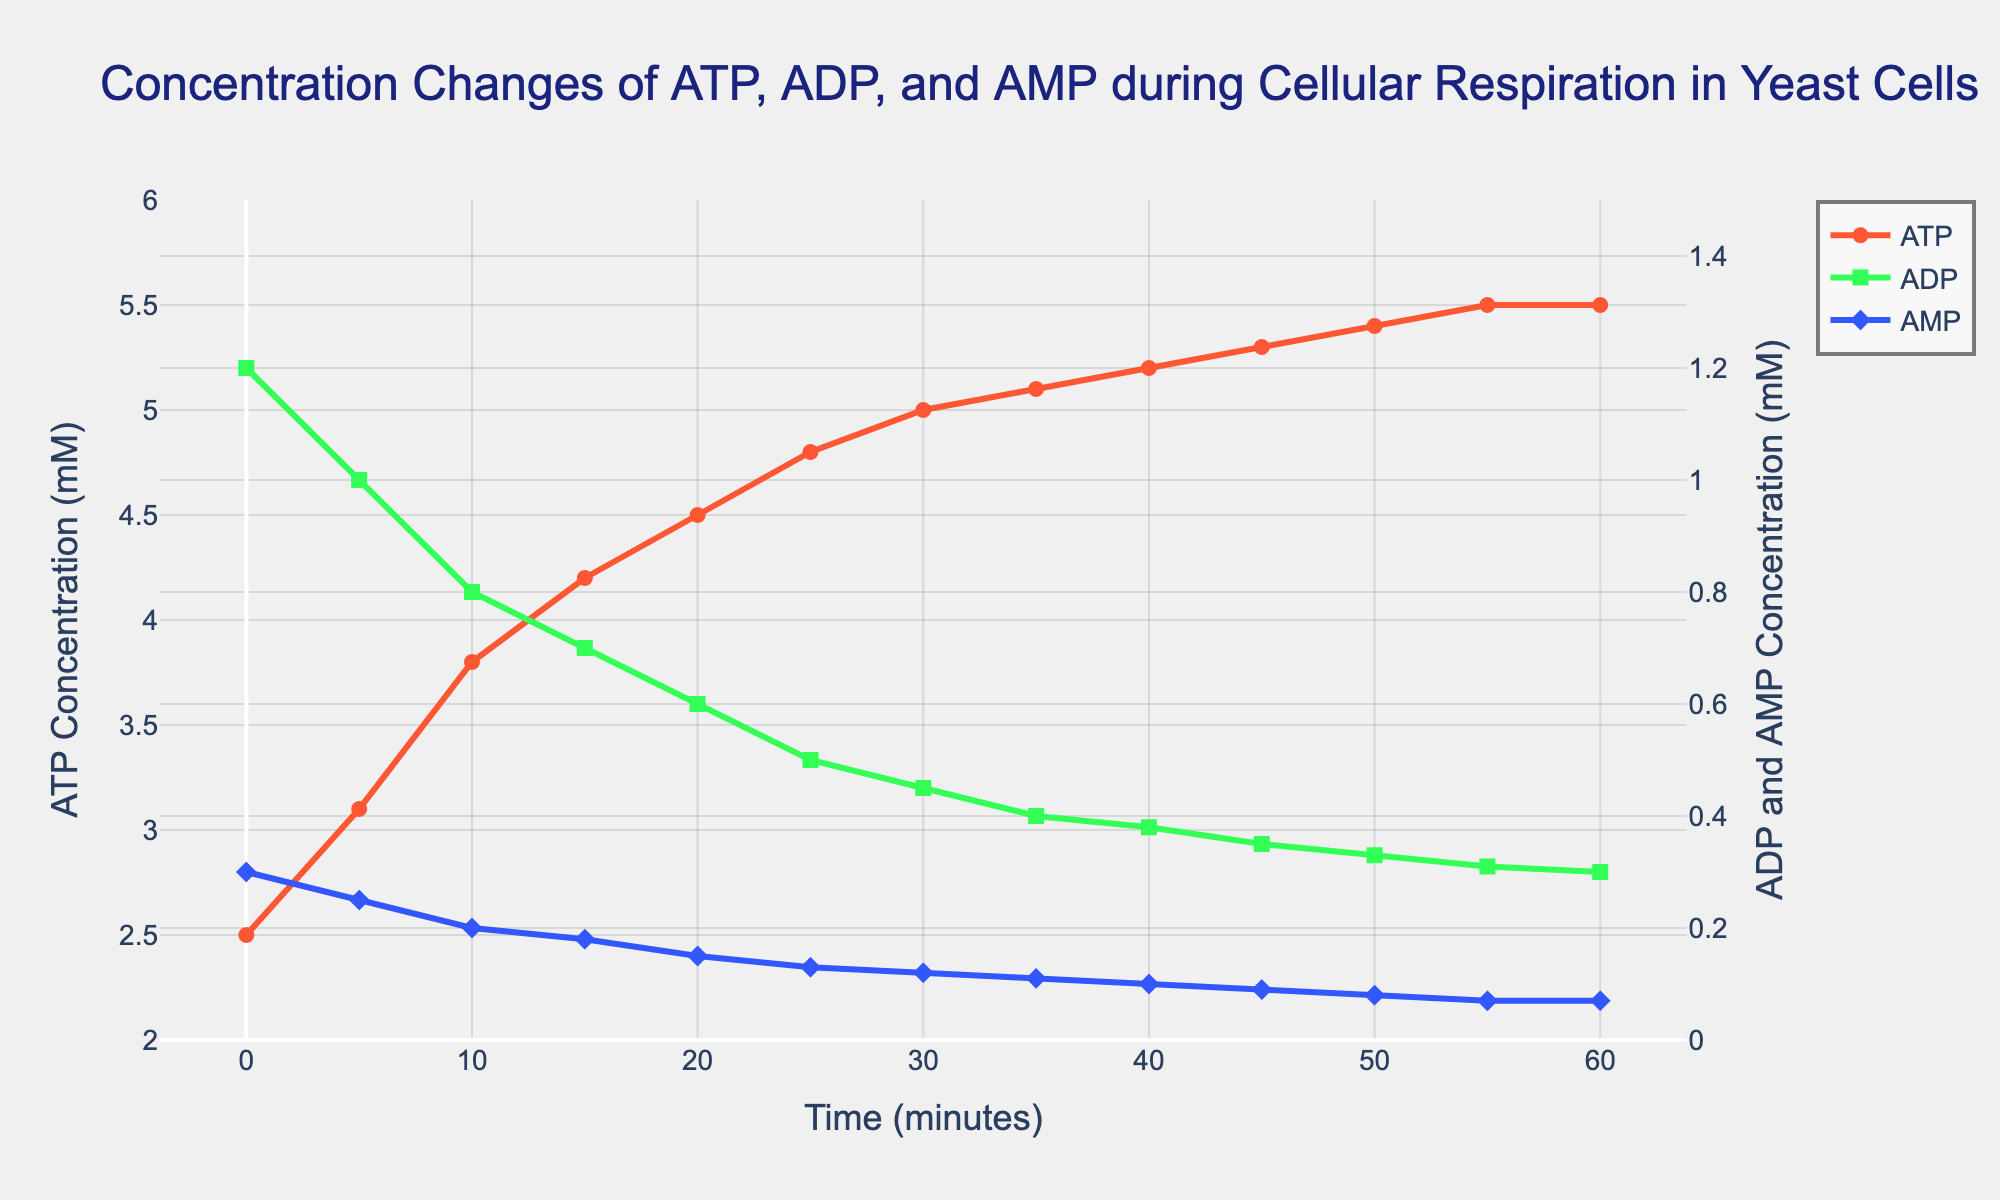Which compound has the highest concentration at the start (0 min)? By examining the values at the start (0 min), ATP has the highest concentration of 2.5 mM compared to ADP (1.2 mM) and AMP (0.3 mM)
Answer: ATP How much does the ATP concentration increase from 0 min to 60 min? The concentration of ATP at 0 min is 2.5 mM and at 60 min is 5.5 mM. The increase is 5.5 - 2.5 = 3 mM
Answer: 3 mM Between which time intervals does the ATP concentration first exceed 4 mM? ATP first exceeds 4 mM between 10 and 15 minutes (4.2 mM at 15 minutes)
Answer: 10-15 minutes What is the difference between the concentrations of ATP and ADP at 45 min? At 45 min, ATP is 5.3 mM and ADP is 0.35 mM. The difference is 5.3 - 0.35 = 4.95 mM
Answer: 4.95 mM Which compound shows the smallest decrease over time? By comparing the changes in ADP and AMP, AMP goes from 0.3 mM to 0.07 mM, a decrease of 0.23 mM, while ADP goes from 1.2 mM to 0.3 mM, a decrease of 0.9 mM. AMP's decrease is smaller
Answer: AMP At what time does ATP reach its maximum concentration? ATP concentration reaches its peak at 55 min and stays constant till 60 min at 5.5 mM
Answer: 55 min Order the concentration of ATP at different time points: 0 min, 30 min, and 60 min, from lowest to highest. Concentrations are 2.5 mM at 0 min, 5.0 mM at 30 min, and 5.5 mM at 60 min. Ordered from lowest to highest: 0 min < 30 min < 60 min
Answer: 0 min < 30 min < 60 min Calculate the average AMP concentration between 20 min and 50 min. AMP concentrations at 20, 25, 30, 35, 40, 45, and 50 min are 0.15, 0.13, 0.12, 0.11, 0.1, 0.09, and 0.08 respectively. The average is (0.15 + 0.13 + 0.12 + 0.11 + 0.1 + 0.09 + 0.08) / 7 = 0.11 mM
Answer: 0.11 mM Compare the rates of decrease for ADP and AMP from 0 to 30 min and identify which one decreases faster. ADP decreases from 1.2 mM to 0.45 mM, a difference of 1.2 - 0.45 = 0.75 mM in 30 min. AMP decreases from 0.3 mM to 0.12 mM, a difference of 0.3 - 0.12 = 0.18 mM in 30 min. ADP decreases faster
Answer: ADP How does the concentration trend of ATP compare to that of ADP over time? ATP concentration consistently increases over time, from 2.5 mM to 5.5 mM. Conversely, ADP concentration consistently decreases from 1.2 mM to 0.3 mM
Answer: ATP increases, ADP decreases 